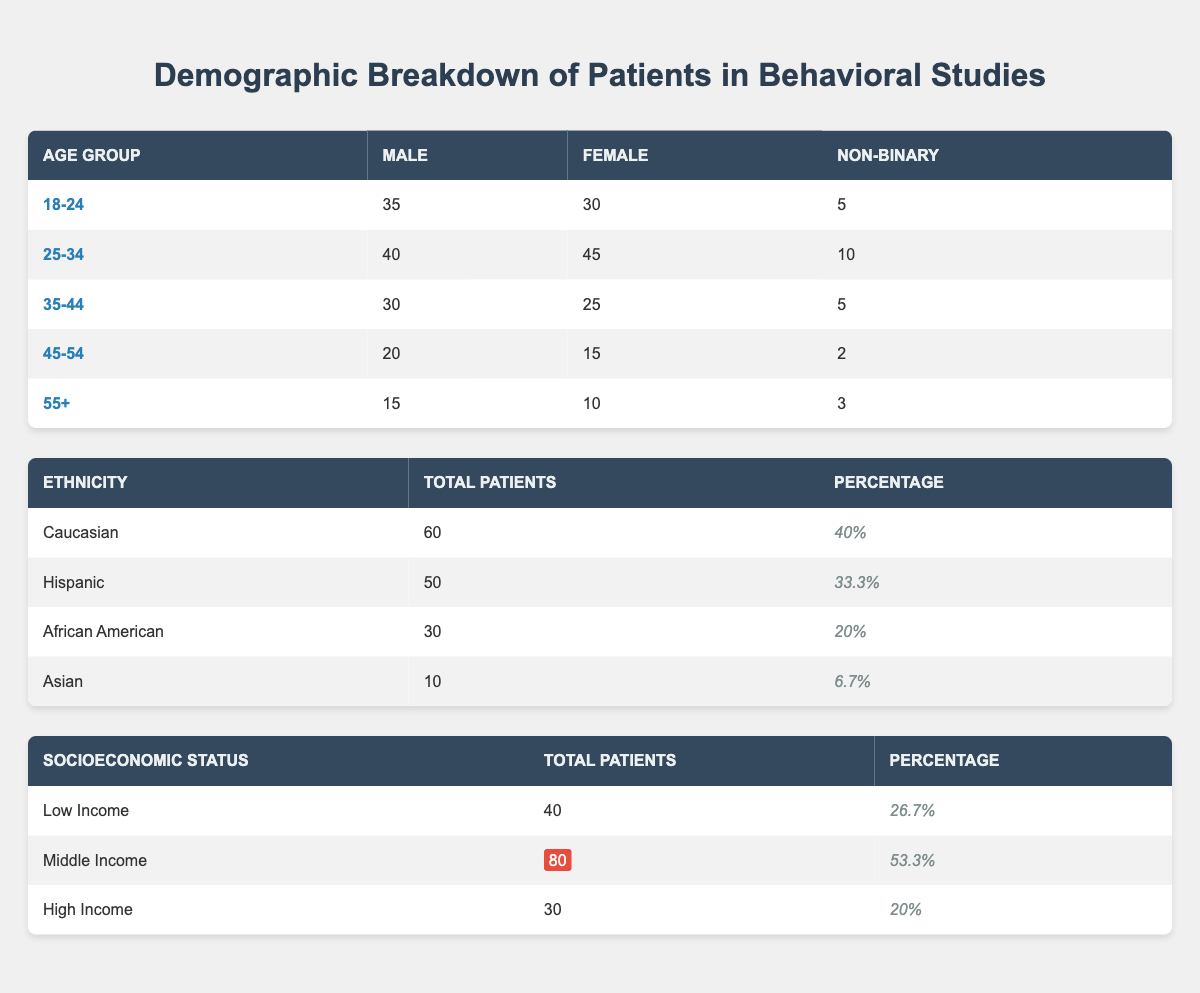What is the total number of males in the age group 25-34? The table shows that the number of males in the age group 25-34 is listed as 40.
Answer: 40 How many more females are there in the age group 18-24 compared to the age group 35-44? The number of females in the age group 18-24 is 30 while in the age group 35-44 it is 25. The difference is 30 - 25 = 5.
Answer: 5 Is the percentage of Caucasian patients higher than that of African American patients? The percentage of Caucasian patients is 40%, and for African American patients, it is 20%. Since 40% is greater than 20%, the statement is true.
Answer: Yes What is the total number of patients from all income levels? The total number of patients can be calculated by adding the totals of each income level: 40 (Low Income) + 80 (Middle Income) + 30 (High Income) = 150.
Answer: 150 Which age group has the highest number of non-binary patients? By examining the table, the age group 25-34 has the highest number of non-binary patients at 10, compared to other age groups which have lower values.
Answer: 10 What is the average number of patients across all ethnicities? The total number of patients across ethnicities is 60 (Caucasian) + 50 (Hispanic) + 30 (African American) + 10 (Asian) = 150. The average is calculated as 150 / 4 = 37.5.
Answer: 37.5 Are there more patients in the middle-income bracket than the combined number of patients in low and high income? The middle-income group has 80 patients. Low income has 40 patients, and high income has 30 patients, together 40 + 30 = 70. Since 80 is greater than 70, the statement is true.
Answer: Yes What is the total percentage of patients from low-income and high-income categories combined? The combined percentage is calculated by adding the two percentages: 26.7% (Low Income) + 20% (High Income) = 46.7%.
Answer: 46.7% 